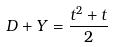<formula> <loc_0><loc_0><loc_500><loc_500>D + Y = \frac { t ^ { 2 } + t } { 2 }</formula> 